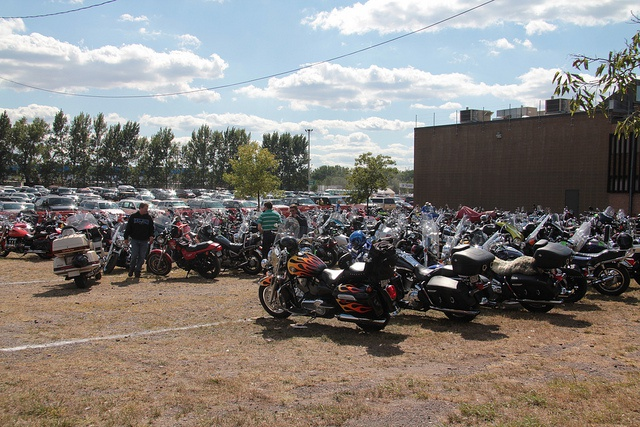Describe the objects in this image and their specific colors. I can see motorcycle in lightblue, black, gray, darkgray, and maroon tones, motorcycle in lightblue, black, gray, and maroon tones, motorcycle in lightblue, black, gray, darkgray, and lightgray tones, motorcycle in lightblue, black, gray, darkgray, and maroon tones, and motorcycle in lightblue, black, gray, darkgray, and tan tones in this image. 